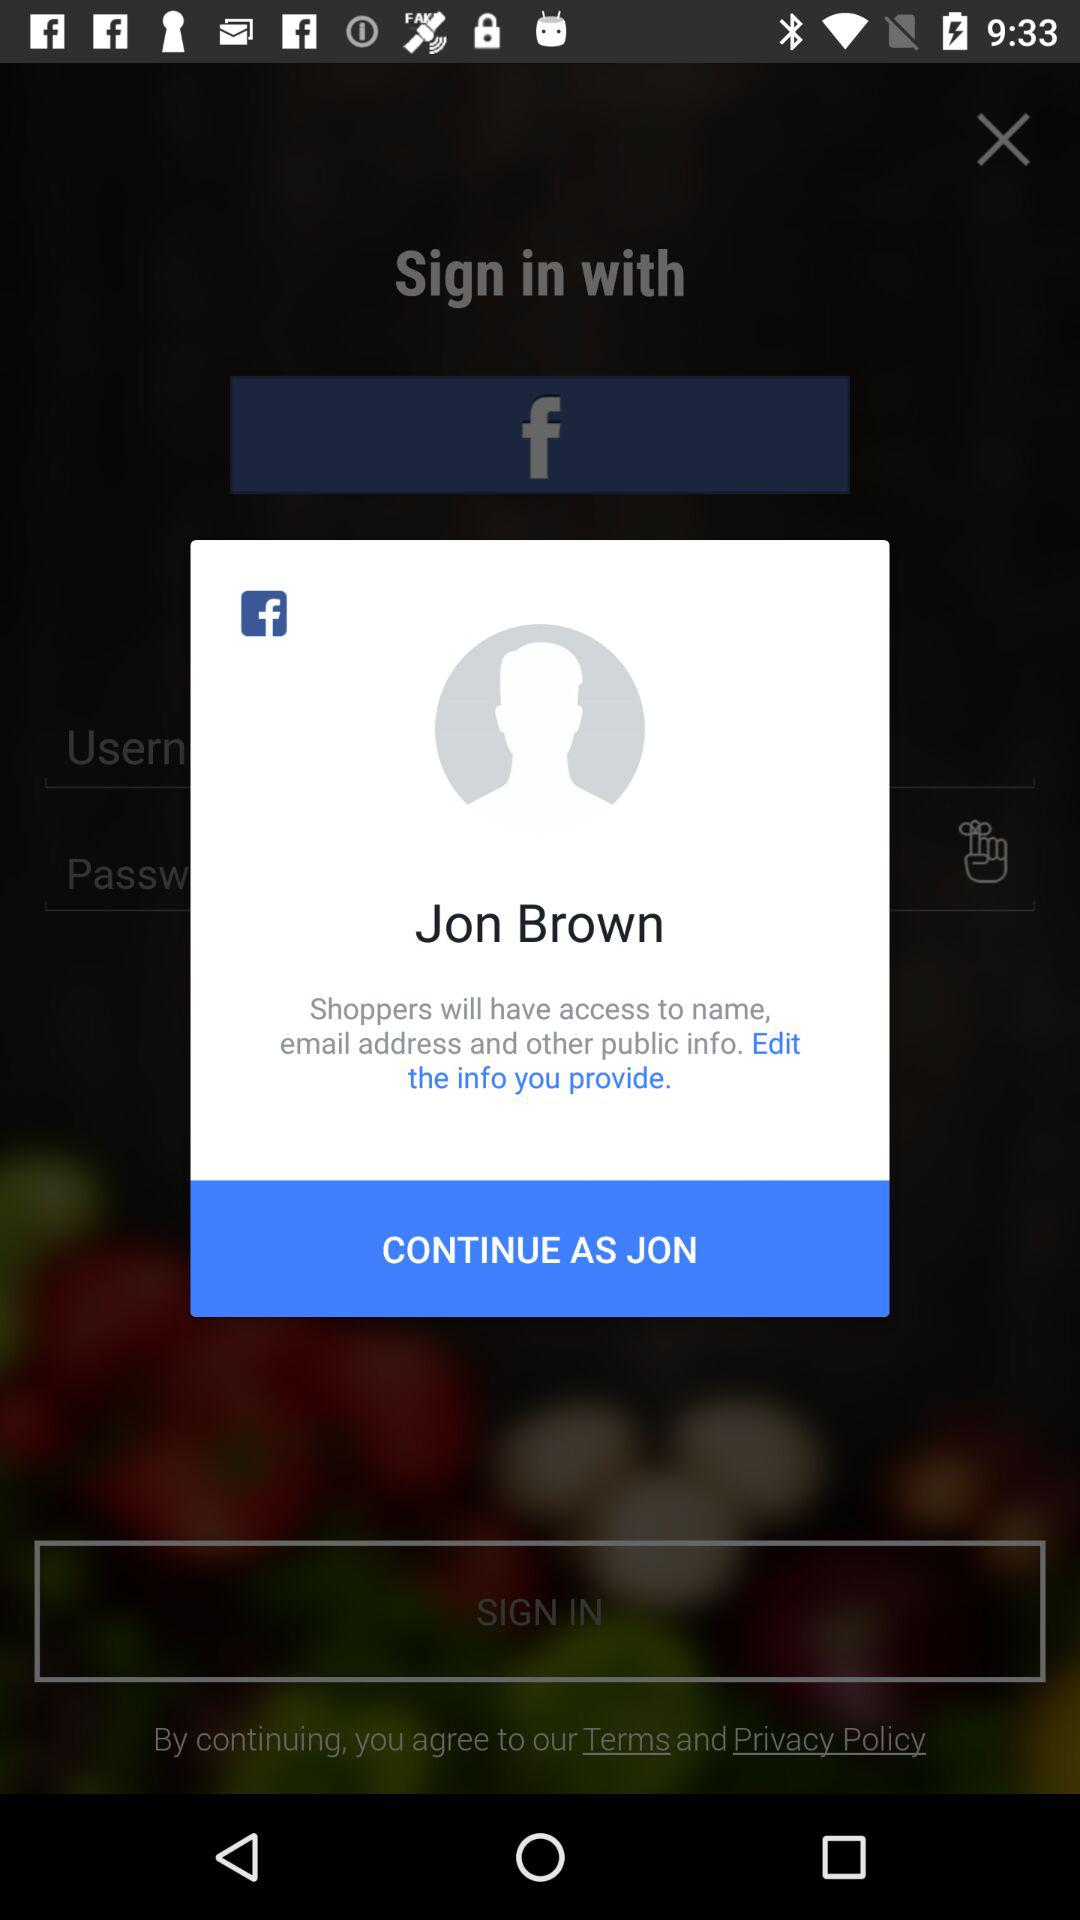Who will have the access to name, email and other public info? The one who will have access to name, email and other public info is "Shoppers". 